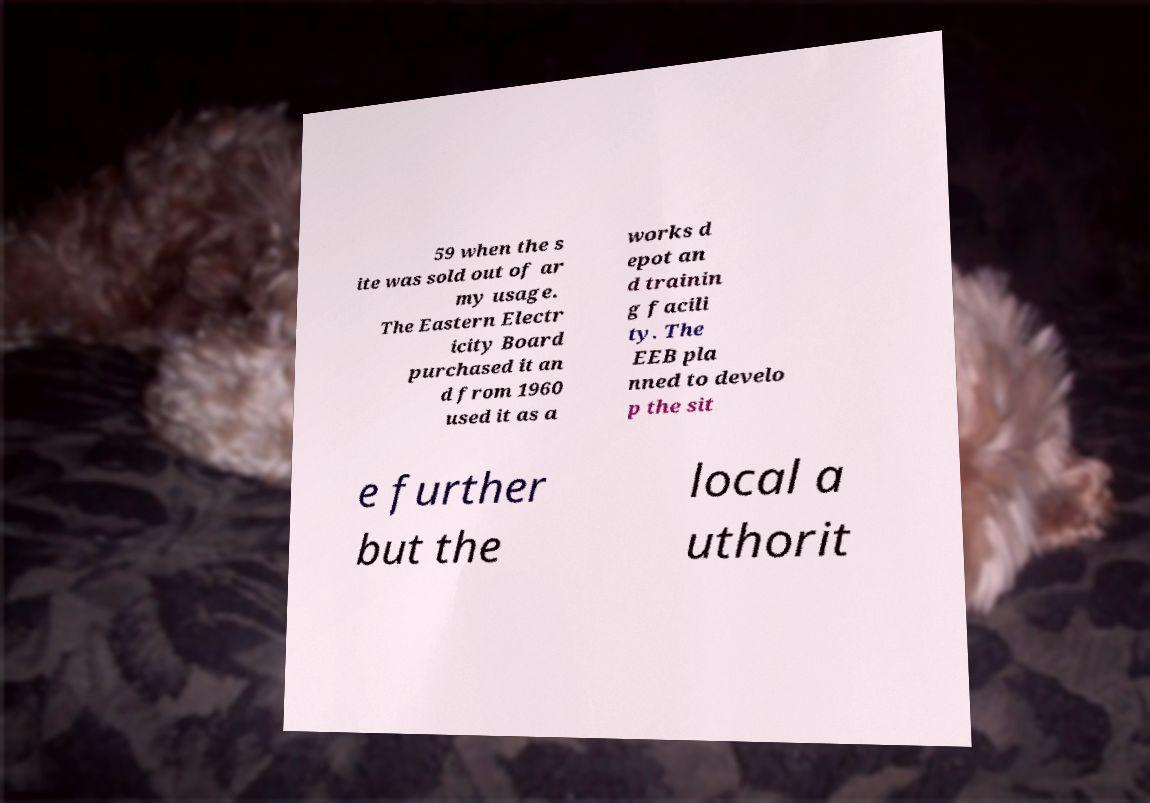There's text embedded in this image that I need extracted. Can you transcribe it verbatim? 59 when the s ite was sold out of ar my usage. The Eastern Electr icity Board purchased it an d from 1960 used it as a works d epot an d trainin g facili ty. The EEB pla nned to develo p the sit e further but the local a uthorit 